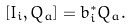Convert formula to latex. <formula><loc_0><loc_0><loc_500><loc_500>\left [ I _ { i } , Q _ { a } \right ] = b _ { i } ^ { \ast } Q _ { a } .</formula> 